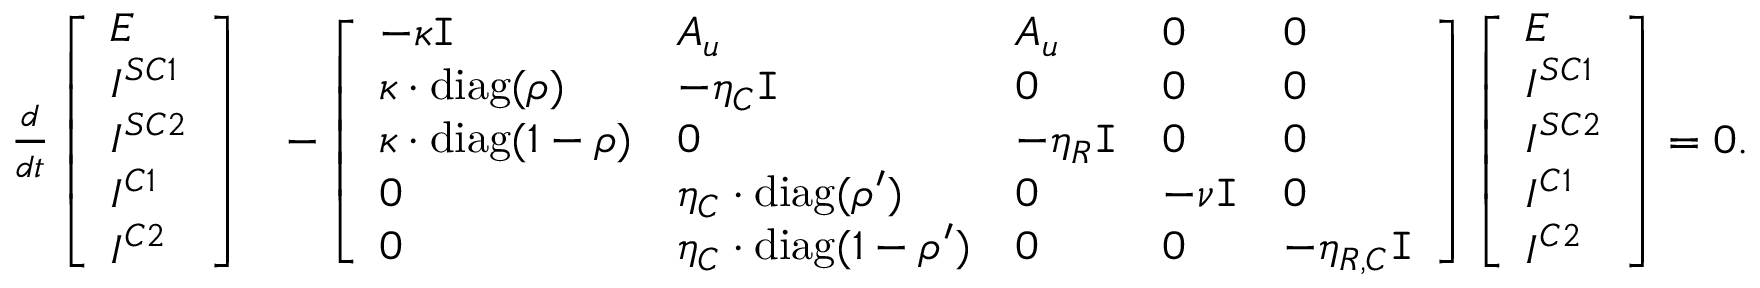<formula> <loc_0><loc_0><loc_500><loc_500>\begin{array} { r l } { \frac { d } { d t } \left [ \begin{array} { l } { E } \\ { I ^ { S C 1 } } \\ { I ^ { S C 2 } } \\ { I ^ { C 1 } } \\ { I ^ { C 2 } } \end{array} \right ] } & { - \left [ \begin{array} { l l l l l } { - \kappa I } & { A _ { u } } & { A _ { u } } & { 0 } & { 0 } \\ { \kappa \cdot d i a g ( \rho ) } & { - \eta _ { C } I } & { 0 } & { 0 } & { 0 } \\ { \kappa \cdot d i a g ( 1 - \rho ) } & { 0 } & { - \eta _ { R } I } & { 0 } & { 0 } \\ { 0 } & { \eta _ { C } \cdot d i a g ( \rho ^ { \prime } ) } & { 0 } & { - \nu I } & { 0 } \\ { 0 } & { \eta _ { C } \cdot d i a g ( 1 - \rho ^ { \prime } ) } & { 0 } & { 0 } & { - \eta _ { R , C } I } \end{array} \right ] \left [ \begin{array} { l } { E } \\ { I ^ { S C 1 } } \\ { I ^ { S C 2 } } \\ { I ^ { C 1 } } \\ { I ^ { C 2 } } \end{array} \right ] = 0 . } \end{array}</formula> 